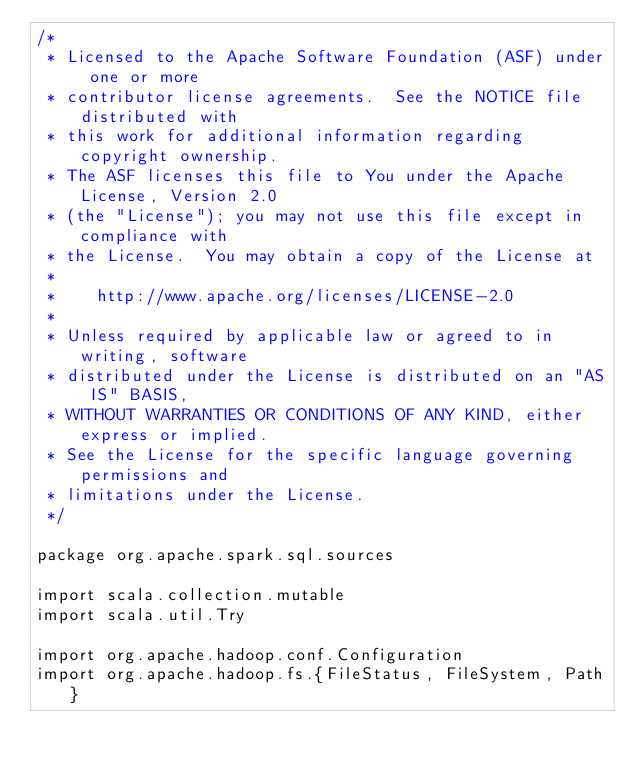Convert code to text. <code><loc_0><loc_0><loc_500><loc_500><_Scala_>/*
 * Licensed to the Apache Software Foundation (ASF) under one or more
 * contributor license agreements.  See the NOTICE file distributed with
 * this work for additional information regarding copyright ownership.
 * The ASF licenses this file to You under the Apache License, Version 2.0
 * (the "License"); you may not use this file except in compliance with
 * the License.  You may obtain a copy of the License at
 *
 *    http://www.apache.org/licenses/LICENSE-2.0
 *
 * Unless required by applicable law or agreed to in writing, software
 * distributed under the License is distributed on an "AS IS" BASIS,
 * WITHOUT WARRANTIES OR CONDITIONS OF ANY KIND, either express or implied.
 * See the License for the specific language governing permissions and
 * limitations under the License.
 */

package org.apache.spark.sql.sources

import scala.collection.mutable
import scala.util.Try

import org.apache.hadoop.conf.Configuration
import org.apache.hadoop.fs.{FileStatus, FileSystem, Path}</code> 